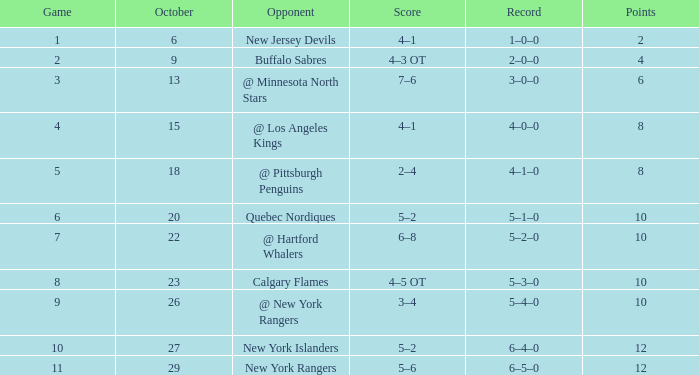Which October has a Record of 5–1–0, and a Game larger than 6? None. 